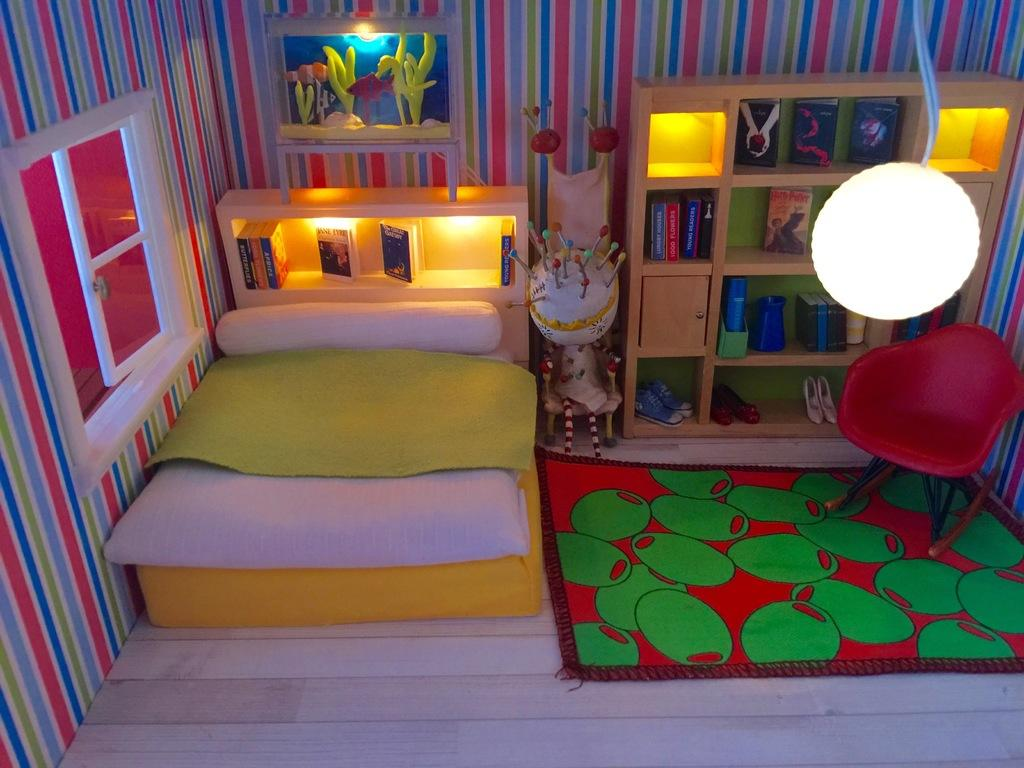Where was the image taken? The image was taken in a room. What furniture is present in the room? There is a bed, a pillow, a chair, and bookshelves in the room. What can be seen through the window in the room? The details of what can be seen through the window are not provided in the facts. What is the source of light in the room? There is a light on the top of the room. What items can be found on the bookshelves? There are books in the bookshelves. What is the doctor's tendency when they see the skate in the room? There is no doctor or skate present in the image, so it is not possible to answer this question. 